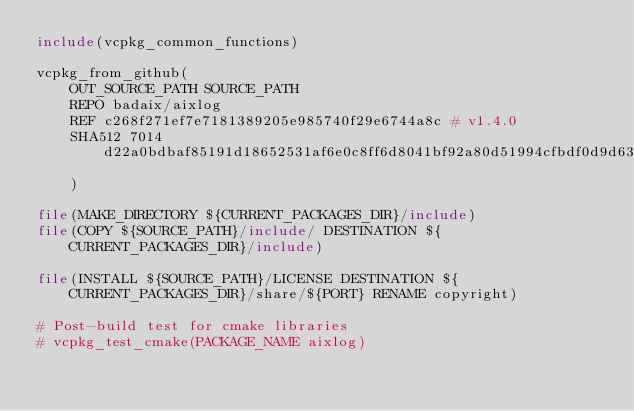Convert code to text. <code><loc_0><loc_0><loc_500><loc_500><_CMake_>include(vcpkg_common_functions)

vcpkg_from_github(
    OUT_SOURCE_PATH SOURCE_PATH
    REPO badaix/aixlog
    REF c268f271ef7e7181389205e985740f29e6744a8c # v1.4.0
    SHA512 7014d22a0bdbaf85191d18652531af6e0c8ff6d8041bf92a80d51994cfbdf0d9d63c4f8836b9bba16d1895ffa03ad0749a42bd11706eb5f3cde1dcbe76746c24
    )
    
file(MAKE_DIRECTORY ${CURRENT_PACKAGES_DIR}/include)
file(COPY ${SOURCE_PATH}/include/ DESTINATION ${CURRENT_PACKAGES_DIR}/include)

file(INSTALL ${SOURCE_PATH}/LICENSE DESTINATION ${CURRENT_PACKAGES_DIR}/share/${PORT} RENAME copyright)

# Post-build test for cmake libraries
# vcpkg_test_cmake(PACKAGE_NAME aixlog)
</code> 